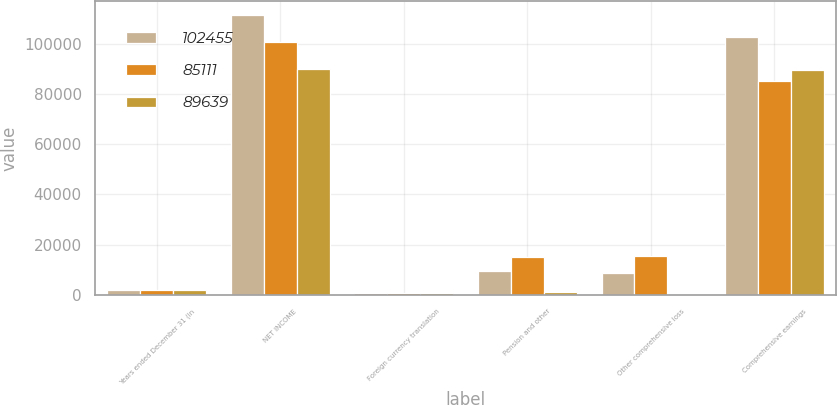Convert chart. <chart><loc_0><loc_0><loc_500><loc_500><stacked_bar_chart><ecel><fcel>Years ended December 31 (in<fcel>NET INCOME<fcel>Foreign currency translation<fcel>Pension and other<fcel>Other comprehensive loss<fcel>Comprehensive earnings<nl><fcel>102455<fcel>2012<fcel>111332<fcel>656<fcel>9533<fcel>8877<fcel>102455<nl><fcel>85111<fcel>2011<fcel>100711<fcel>708<fcel>14892<fcel>15600<fcel>85111<nl><fcel>89639<fcel>2010<fcel>90002<fcel>826<fcel>1189<fcel>363<fcel>89639<nl></chart> 